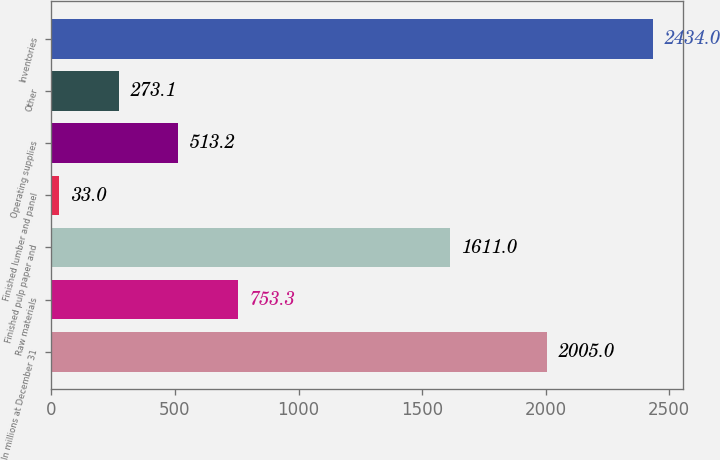Convert chart to OTSL. <chart><loc_0><loc_0><loc_500><loc_500><bar_chart><fcel>In millions at December 31<fcel>Raw materials<fcel>Finished pulp paper and<fcel>Finished lumber and panel<fcel>Operating supplies<fcel>Other<fcel>Inventories<nl><fcel>2005<fcel>753.3<fcel>1611<fcel>33<fcel>513.2<fcel>273.1<fcel>2434<nl></chart> 